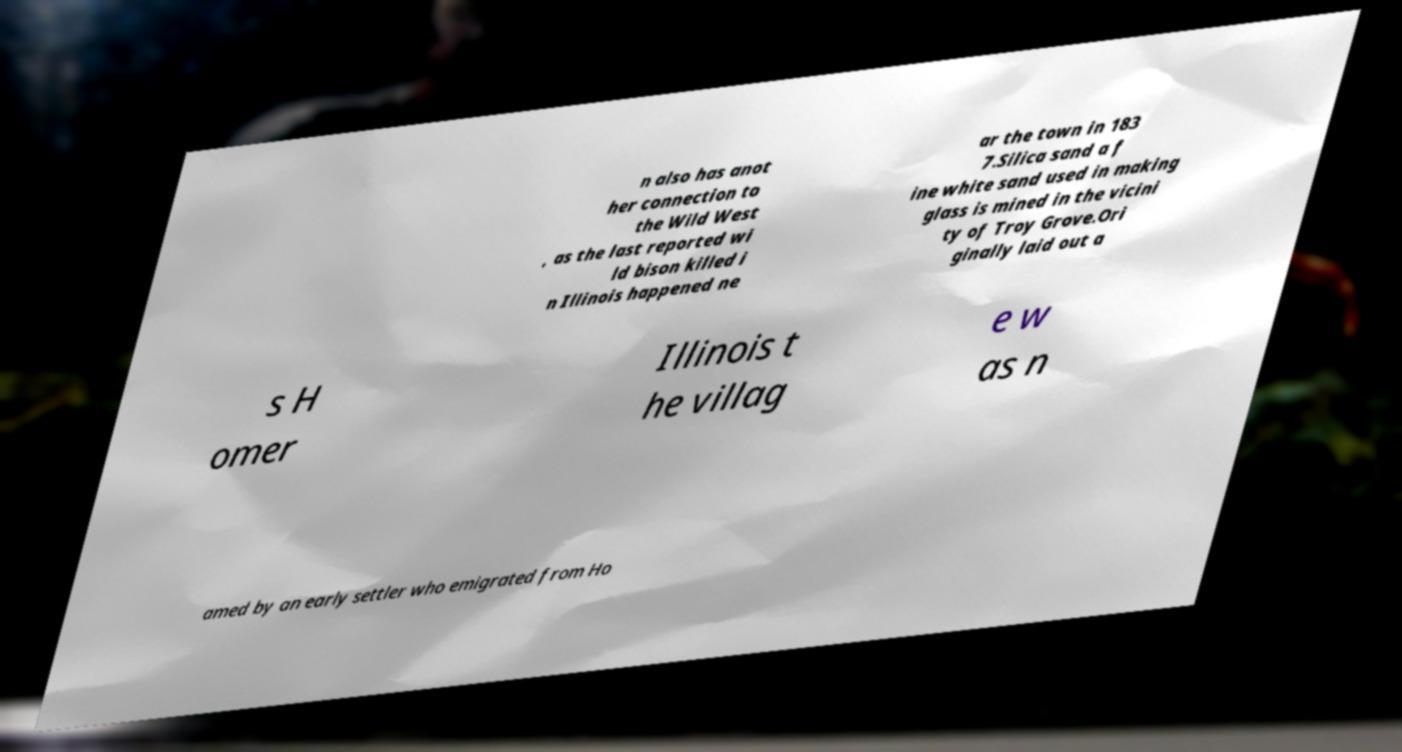I need the written content from this picture converted into text. Can you do that? n also has anot her connection to the Wild West , as the last reported wi ld bison killed i n Illinois happened ne ar the town in 183 7.Silica sand a f ine white sand used in making glass is mined in the vicini ty of Troy Grove.Ori ginally laid out a s H omer Illinois t he villag e w as n amed by an early settler who emigrated from Ho 